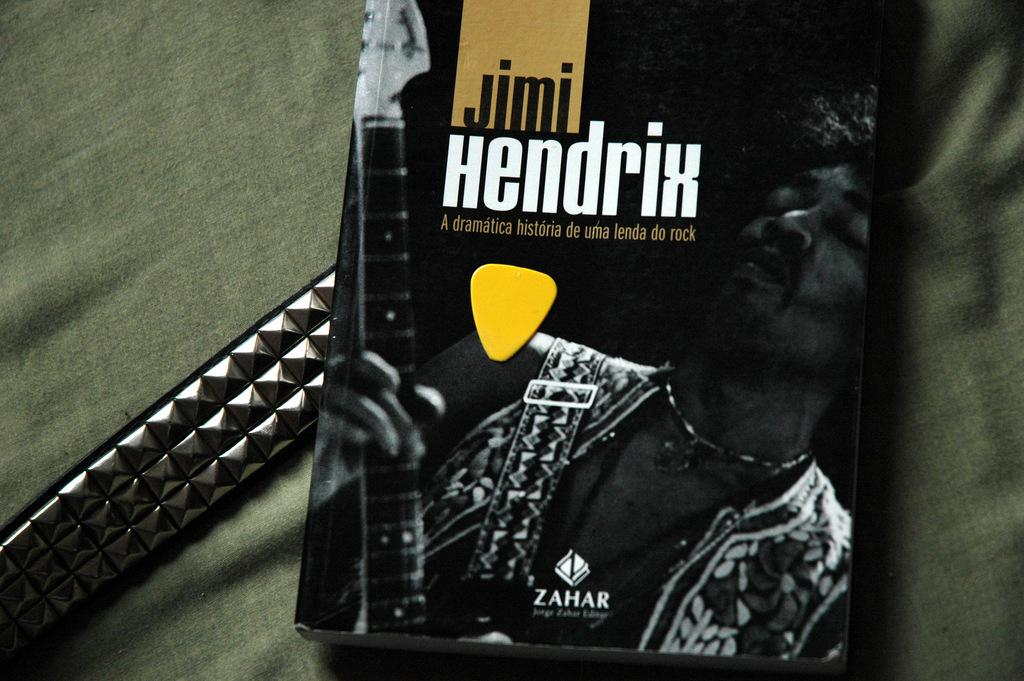Provide a one-sentence caption for the provided image. A Jimi Hendrix guitar book with a pick on it is laying on a metallic belt and all of it on a green fabric. 